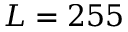<formula> <loc_0><loc_0><loc_500><loc_500>L = 2 5 5</formula> 